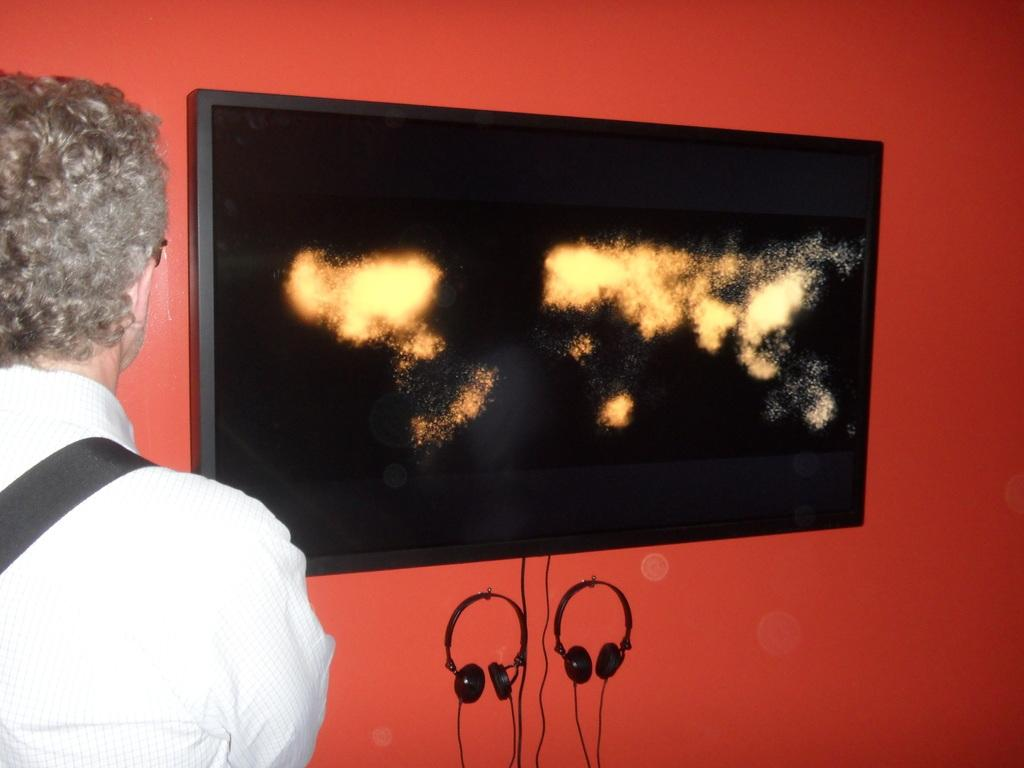What is located on the left side of the image? There is a person on the left side of the image. What can be seen on the wall in the image? There is a screen on the wall. What objects are visible that might be used for amplifying sound? Microphones are visible in the image. Can you see a kite being flown by the person on the left side of the image? There is no kite visible in the image. Is there a baseball game happening in the background of the image? There is no reference to a baseball game or any sports activity in the image. 